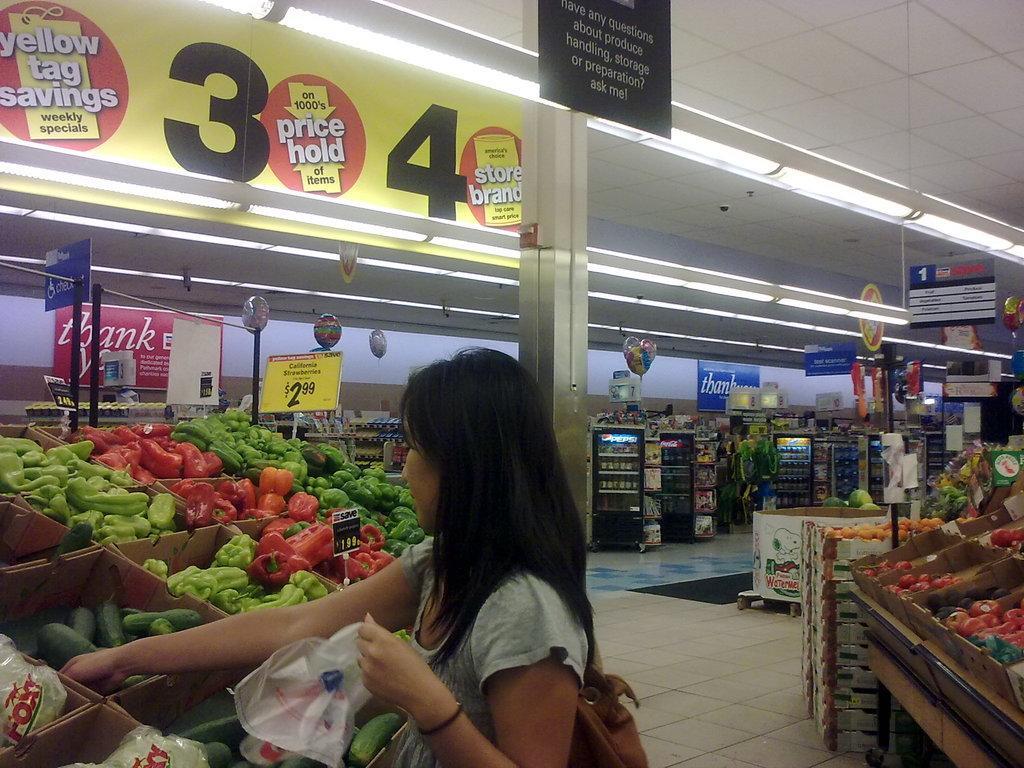How would you summarize this image in a sentence or two? This picture is taken inside the vegetable market. In this image, in the middle, we can see a woman wearing a backpack and holding a cover in her hand is standing in front of the table, on the table, we can see some boxes with some vegetables. On the right side, we can see a table, on the table, we can see some fruits in the boxes. In the background, we can see a refrigerator, board, poster. At the top, we can see a roof, at the bottom, we can see a floor and a mat. 